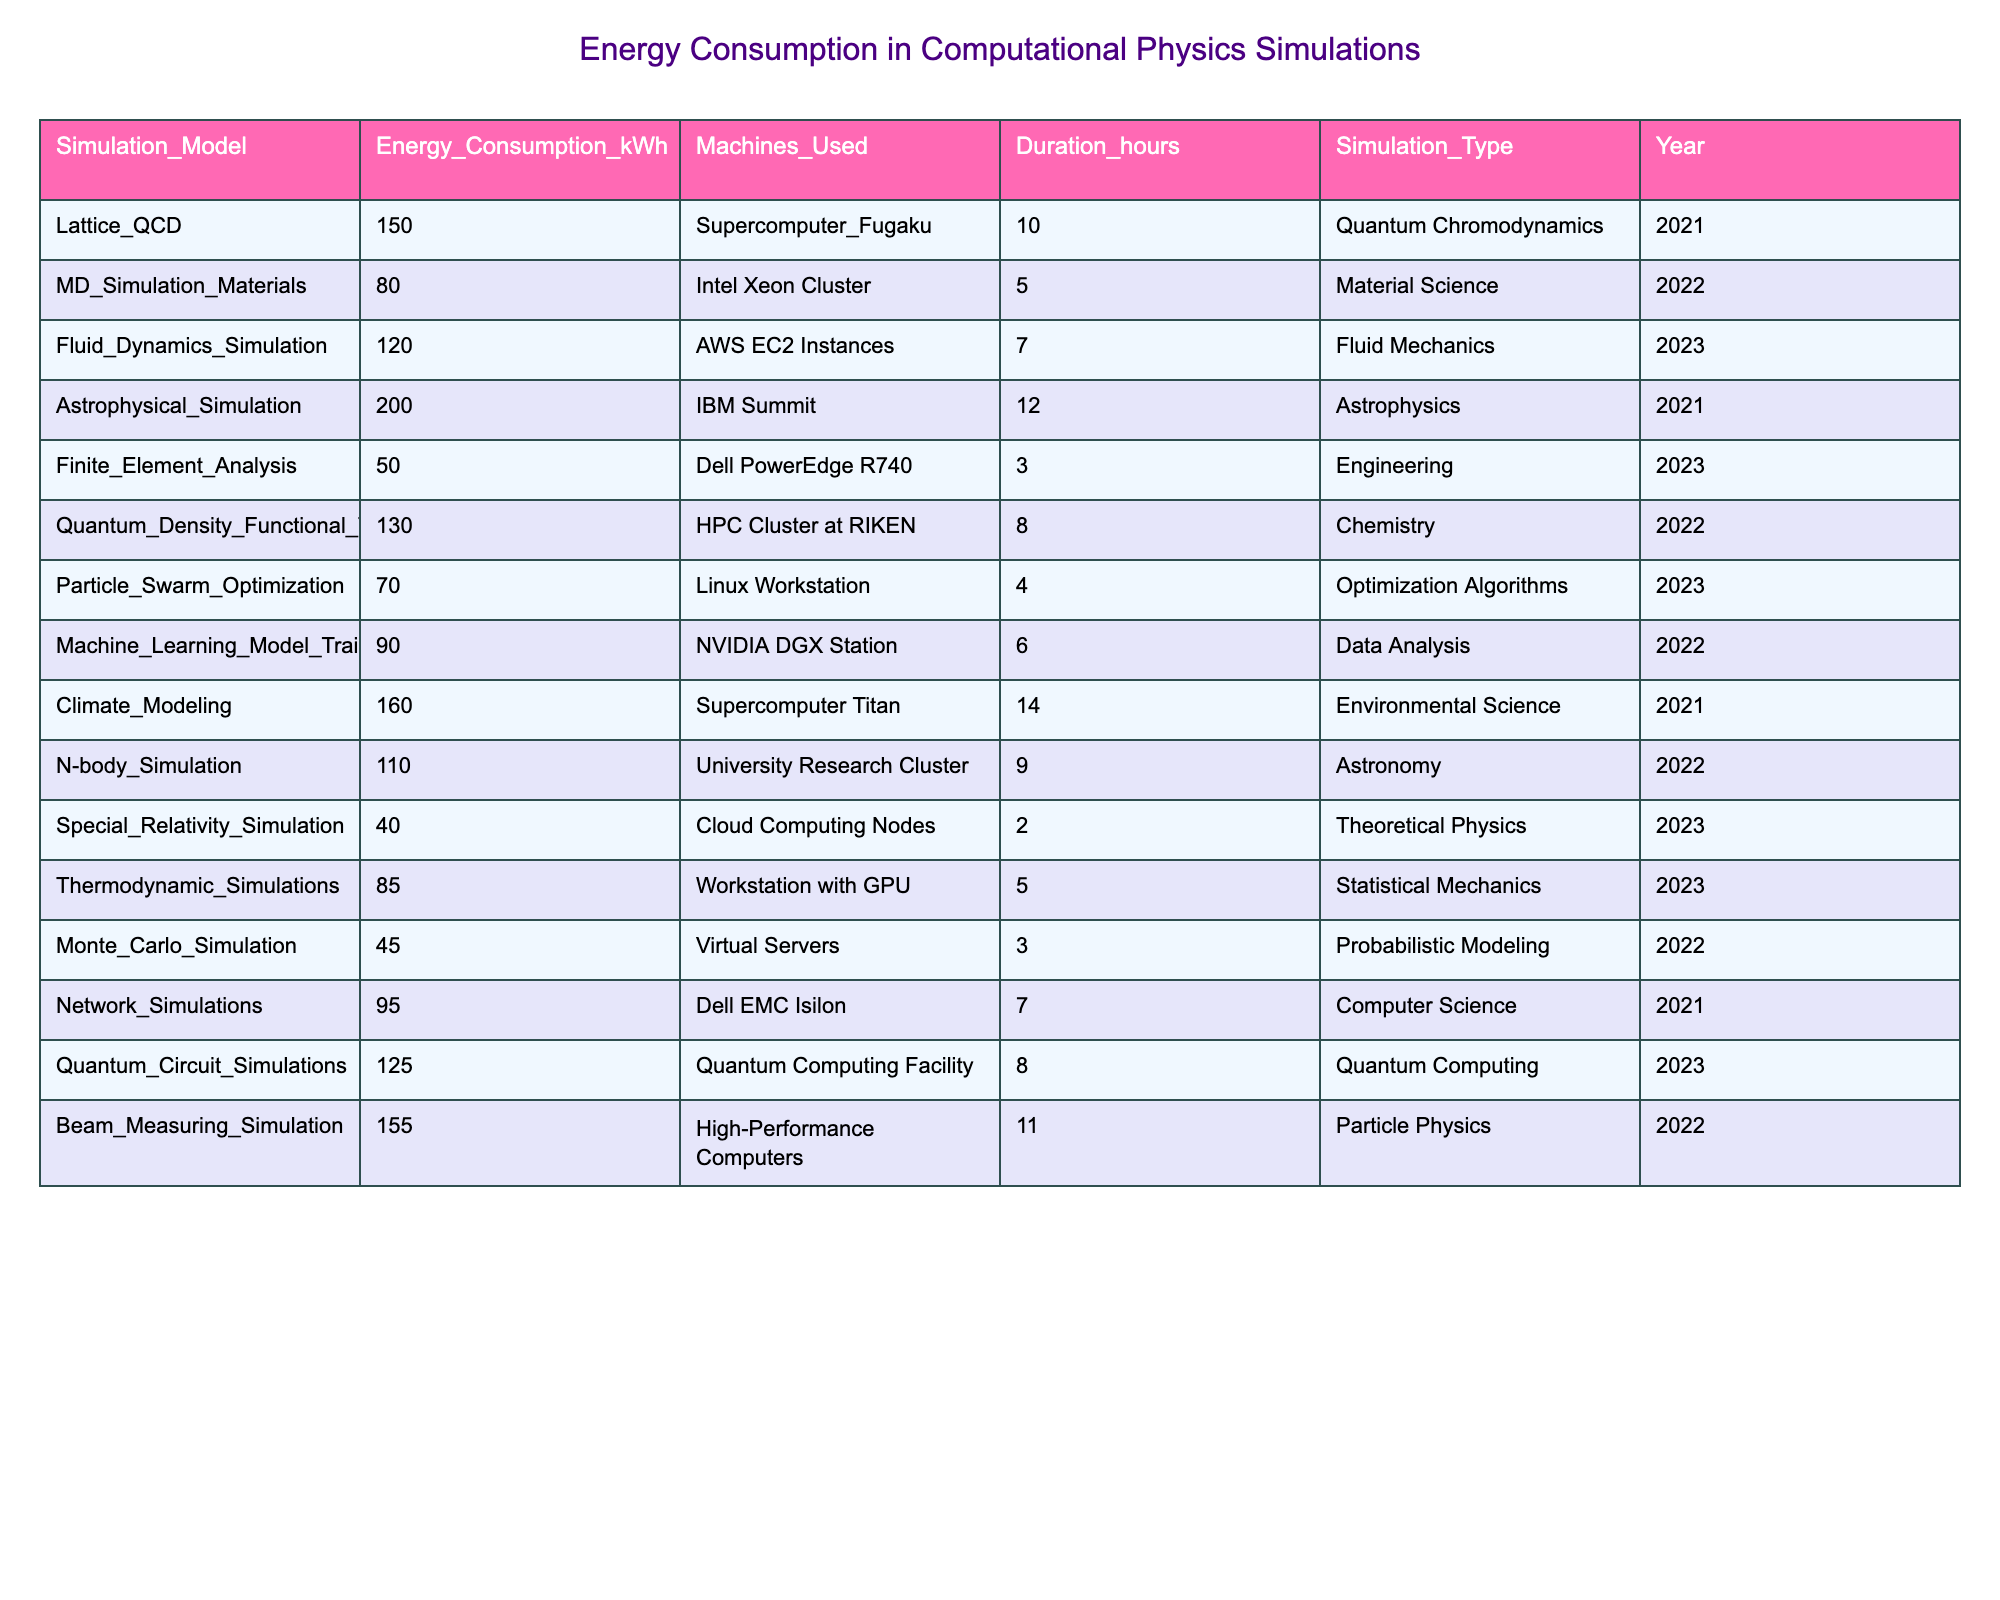What is the total energy consumption of all simulations listed? To find the total energy consumption, I sum the energy consumption values from each row in the table: 150 + 80 + 120 + 200 + 50 + 130 + 70 + 90 + 160 + 110 + 40 + 85 + 45 + 95 + 125 + 155 = 1,680 kWh.
Answer: 1680 kWh Which simulation type has the highest energy consumption? By examining the Energy Consumption column, I find the maximum value is 200 kWh, corresponding to the Astrophysical Simulation.
Answer: Astrophysical Simulation How many simulations were conducted using supercomputers? I count the occurrences of 'Supercomputer' in the Machines Used column, and find there are 3 instances: Lattice QCD, Climate Modeling, and the Fluid Dynamics Simulation.
Answer: 3 What is the average energy consumption for simulations done in 2022? I first filter the table for simulations in 2022, which give the energies: 80, 130, 90, and 110. Summing them yields 80 + 130 + 90 + 110 = 410, and there are 4 simulations. Thus, the average is 410/4 = 102.5 kWh.
Answer: 102.5 kWh Is the energy consumption for the Finite Element Analysis simulation greater than or less than 100 kWh? Looking at the table, the energy consumption for Finite Element Analysis is 50 kWh, which is less than 100 kWh.
Answer: Less than What is the median energy consumption among all simulations? To find the median, I first put the energy consumption values in order: 40, 45, 50, 70, 80, 85, 90, 95, 110, 120, 130, 150, 155, 160, 200. Since there are 15 values (odd), the median is the middle value, which is the 8th number: 95 kWh.
Answer: 95 kWh How does the energy consumption of the Monte Carlo Simulation compare to the average consumption of all simulations? The Monte Carlo Simulation has an energy consumption of 45 kWh. The total energy consumption is 1,680 kWh for 16 simulations, so the average is 1,680/16 = 105 kWh. Since 45 kWh is less than 105 kWh, it consumes less.
Answer: Less than average Which simulation had the longest duration, and what is its energy consumption? The longest duration is 14 hours, which corresponds to Climate Modeling. Its energy consumption is 160 kWh.
Answer: Climate Modeling, 160 kWh How many different machine types were used across all simulations? I examine the Machines Used column for unique entries; they are: Supercomputer Fugaku, Intel Xeon Cluster, AWS EC2 Instances, IBM Summit, Dell PowerEdge R740, HPC Cluster at RIKEN, Linux Workstation, NVIDIA DGX Station, Supercomputer Titan, University Research Cluster, Cloud Computing Nodes, Workstation with GPU, Virtual Servers, Dell EMC Isilon, and Quantum Computing Facility, which totals to 15 different machine types.
Answer: 15 